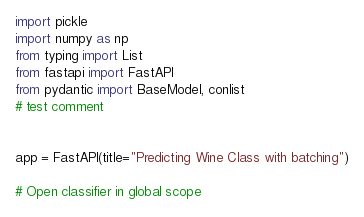<code> <loc_0><loc_0><loc_500><loc_500><_Python_>import pickle
import numpy as np
from typing import List
from fastapi import FastAPI
from pydantic import BaseModel, conlist
# test comment


app = FastAPI(title="Predicting Wine Class with batching")

# Open classifier in global scope</code> 